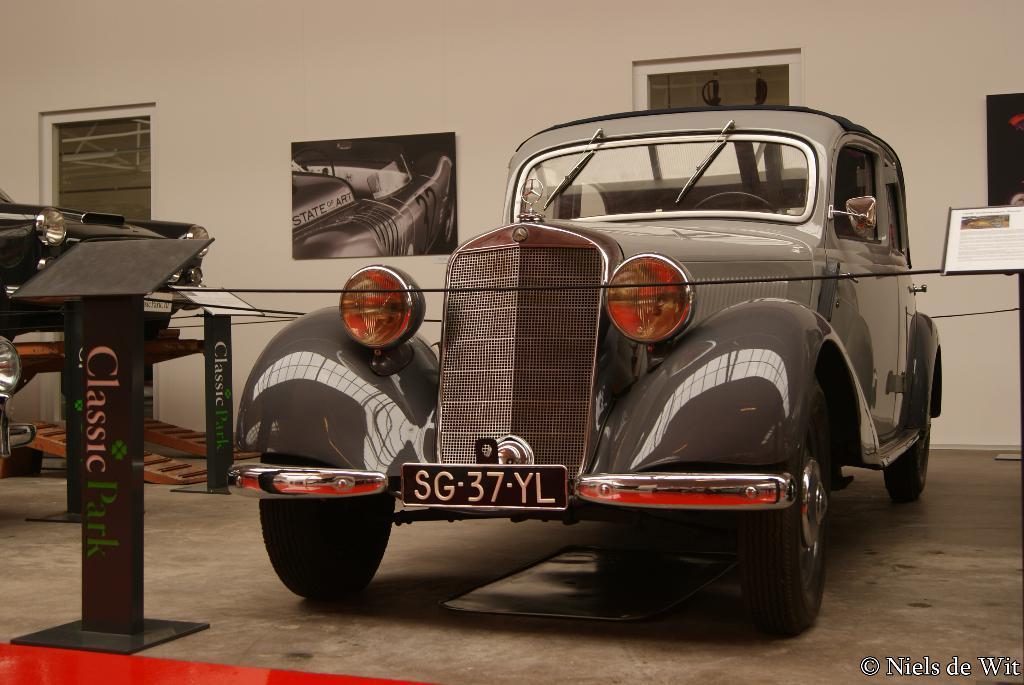In one or two sentences, can you explain what this image depicts? As we can see in the image there is a wall, window, posters and cars. In the front there is a red color mat. 